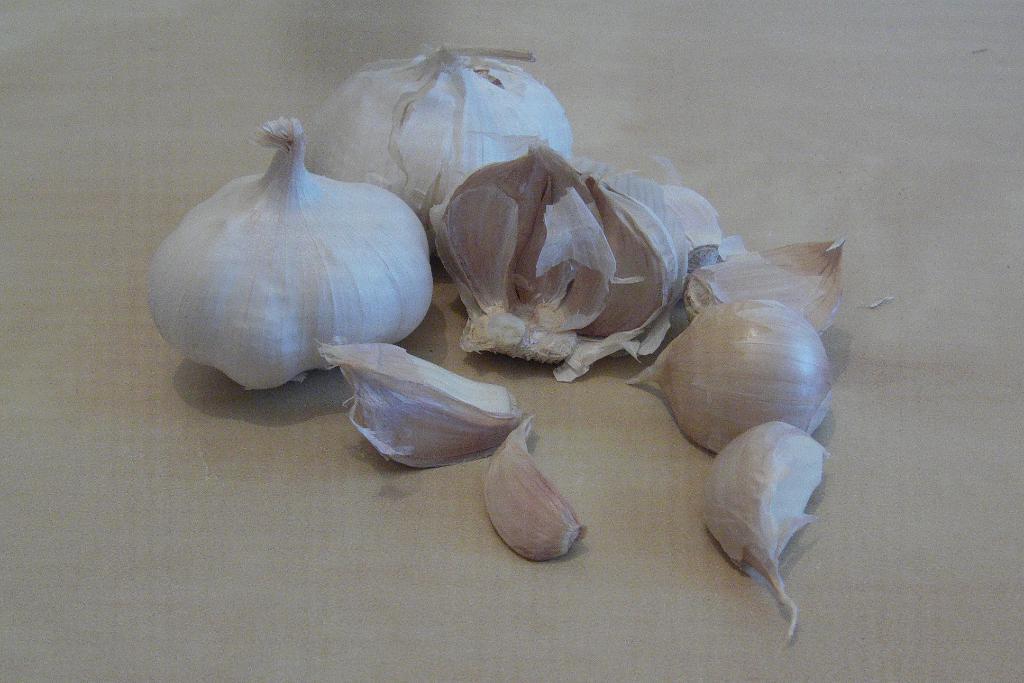Describe this image in one or two sentences. In this image I can see garlic cloves on the floor. 